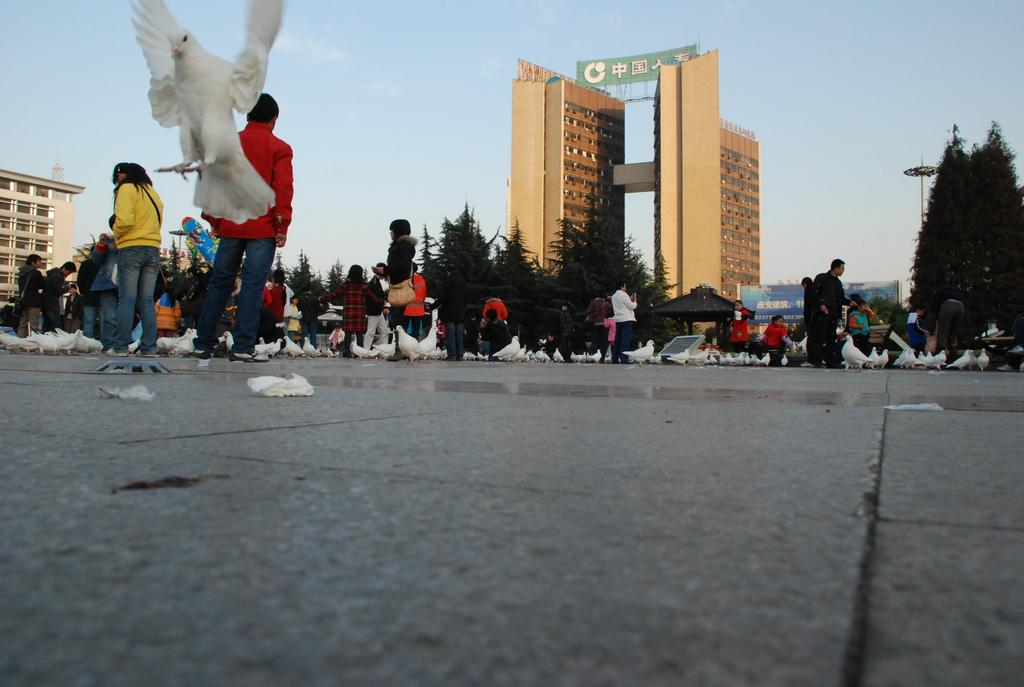How many people are in the image? There is a group of people in the image, but the exact number is not specified. Where are the people standing in the image? The people are standing on a path in the image. What else can be seen in the image besides the people? There are birds, trees, a building, and a hoarding in front of the people, as well as the sky visible in the image. Can you describe the birds in the image? At least one bird is flying in the air in the image. What type of snake can be seen slithering on the hoarding in the image? There is no snake present in the image; it only features a group of people, birds, trees, a building, and a hoarding. 